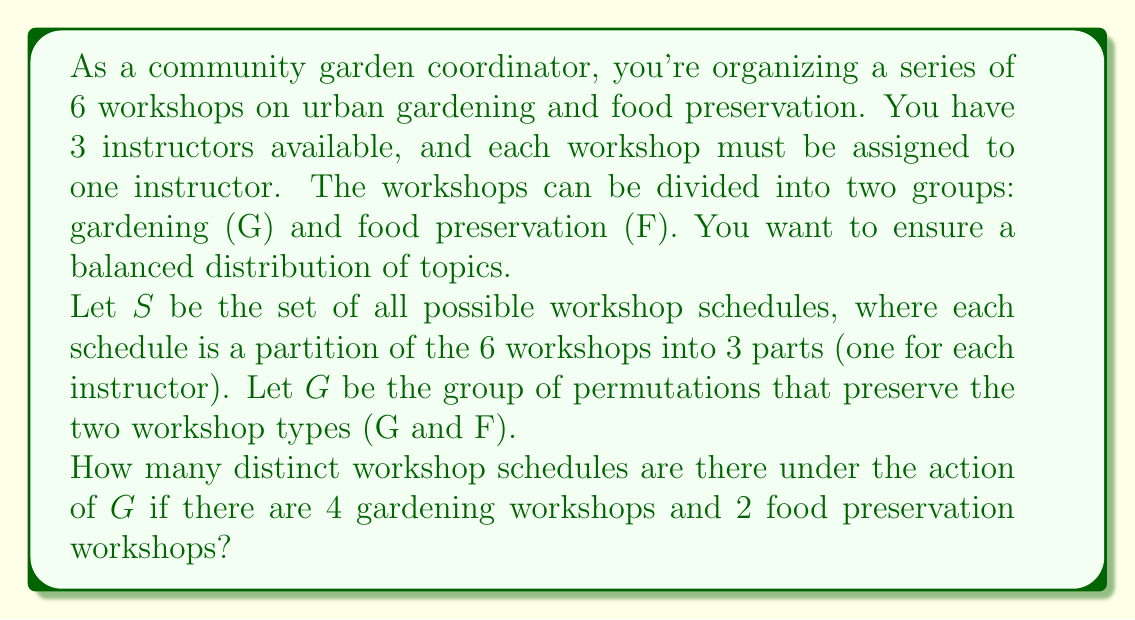Show me your answer to this math problem. Let's approach this step-by-step:

1) First, we need to understand what our set $S$ and group $G$ represent:
   - $S$ is the set of all partitions of 6 workshops into 3 parts.
   - $G$ is the group of permutations that preserve the workshop types (4 G and 2 F).

2) The number of distinct schedules under the action of $G$ is equal to the number of orbits in this group action. We can use Burnside's lemma to calculate this.

3) Burnside's lemma states that the number of orbits is equal to the average number of elements fixed by each group element:

   $$ |S/G| = \frac{1}{|G|} \sum_{g \in G} |S^g| $$

   where $S^g$ is the set of elements in $S$ fixed by $g$.

4) To apply this, we need to consider the cycle structure of permutations in $G$:
   - Identity: (1)(1)(1)(1)(2)
   - 2-cycle on G: (2)(1)(1)(2)
   - 3-cycle on G: (3)(1)(2)
   - 4-cycle on G: (4)(2)
   - Two 2-cycles on G: (2)(2)(2)

5) For each of these cycle types, we need to count how many schedules they fix:
   - Identity: $\binom{6}{2,2,2} / 3! = 15$
   - 2-cycle on G: $\binom{4}{2} \cdot \binom{4}{2,2} / 2! = 18$
   - 3-cycle on G: $\binom{4}{1,1,2} = 12$
   - 4-cycle on G: $3$
   - Two 2-cycles on G: $\binom{4}{2,2} = 3$

6) The size of $G$ is $4! \cdot 2! = 48$

7) Applying Burnside's lemma:

   $$ |S/G| = \frac{1}{48}(15 + 6 \cdot 18 + 8 \cdot 12 + 6 \cdot 3 + 3 \cdot 3) = \frac{237}{48} = 4.9375 $$

8) Since the number of orbits must be an integer, we round this to 5.
Answer: There are 5 distinct workshop schedules under the action of $G$. 